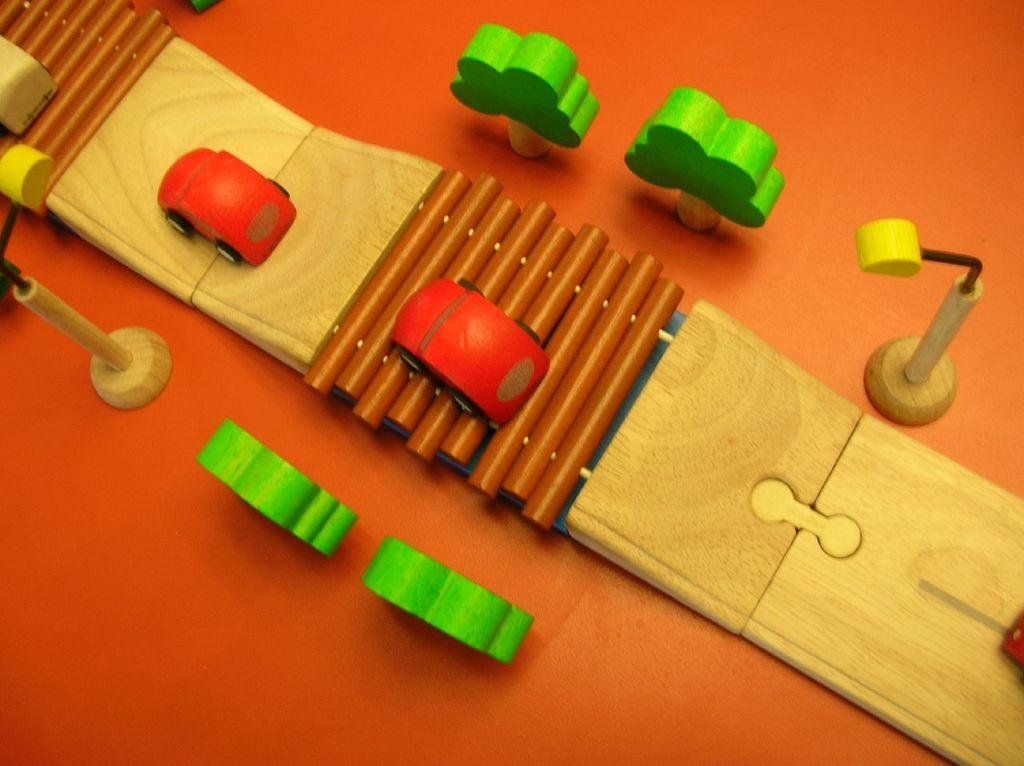What is located in the center of the image? There are toys and a wooden board in the center of the image. Can you describe the wooden board in the image? The wooden board is in the center of the image. What is at the bottom of the image? There is a table at the bottom of the image. What is the reason for the argument between the toys in the image? There is no argument between the toys in the image, as they are inanimate objects. How does the good-bye affect the toys in the image? There is no good-bye in the image, as it is a static scene. 